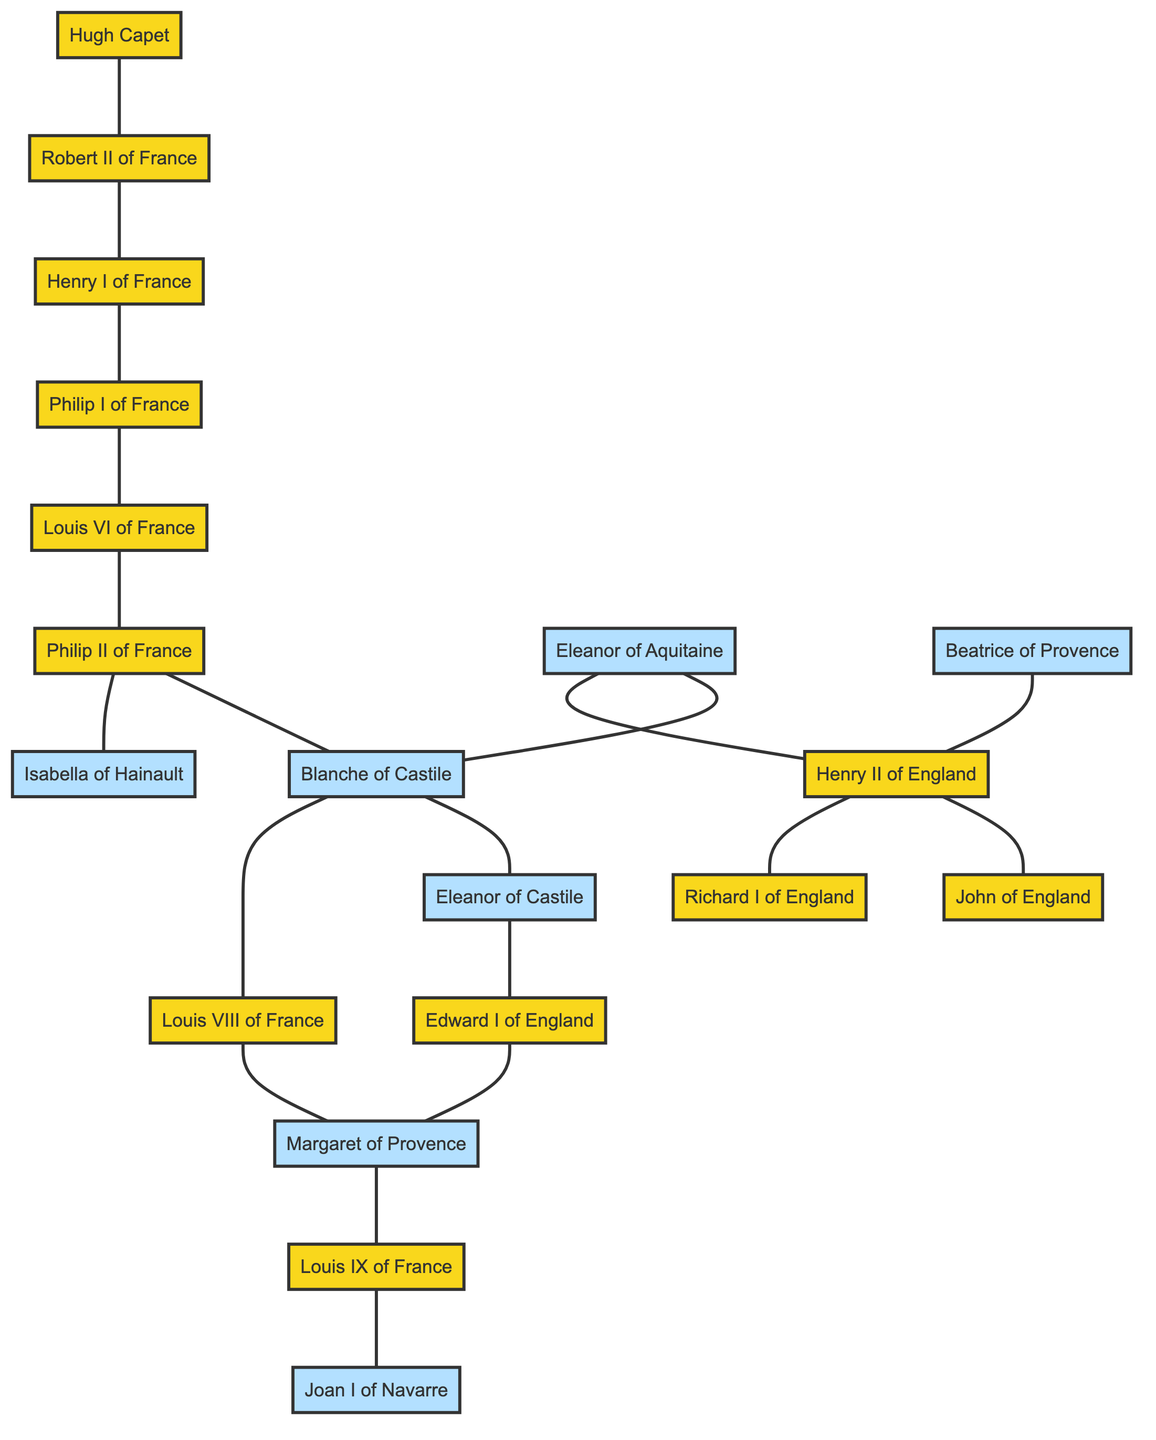What is the relationship between Hugh Capet and Robert II of France? The diagram shows that Hugh Capet is directly connected to Robert II of France with an edge, indicating a parent-child relationship where Hugh Capet is the father of Robert II.
Answer: Father How many nodes are present in the diagram? The diagram includes a total of 17 distinct nodes representing individuals from the Capetian dynasty and their connections, which can be counted from the node list.
Answer: 17 Who is the spouse of Philip II of France? The diagram indicates that Philip II of France is connected to both Isabella of Hainault and Blanche of Castile, implying that both are his spouses. However, the question asks for one; hence either can be considered as a valid answer.
Answer: Isabella of Hainault Which house does Eleanor of Aquitaine belong to? Eleanor of Aquitaine is not connected to any Capetian node directly through a marriage but is connected to Henry II of England, indicating she is a member of the English royal house.
Answer: England What is the total number of edges in the diagram? By counting the edges shown between the nodes, the diagram presents 19 connections representing genealogical relationships among the individuals.
Answer: 19 Which two nodes are connected by the edge labeled as "Louis VIII of France"? The edge of Louis VIII of France connects to his spouse Margaret of Provence as indicated in the diagram, showing their marriage connection.
Answer: Margaret of Provence What type of relationship exists between Henry II of England and Richard I of England? The diagram shows an edge directly connecting Henry II of England to Richard I of England, indicating a parent-child relationship where Henry II is Richard I's father.
Answer: Father How many heirs did Louis IX of France have according to the diagram? The diagram indicates that Louis IX of France has one known connection to his child Joan I of Navarre, showing that he had at least one offspring depicted in this graph.
Answer: 1 Which Capetian king is associated with Eleanor of Castile through marriage? Through observing the edges, Eleanor of Castile is connected to Edward I of England, indicating that she is his spouse and part of his royal lineage.
Answer: Edward I of England 